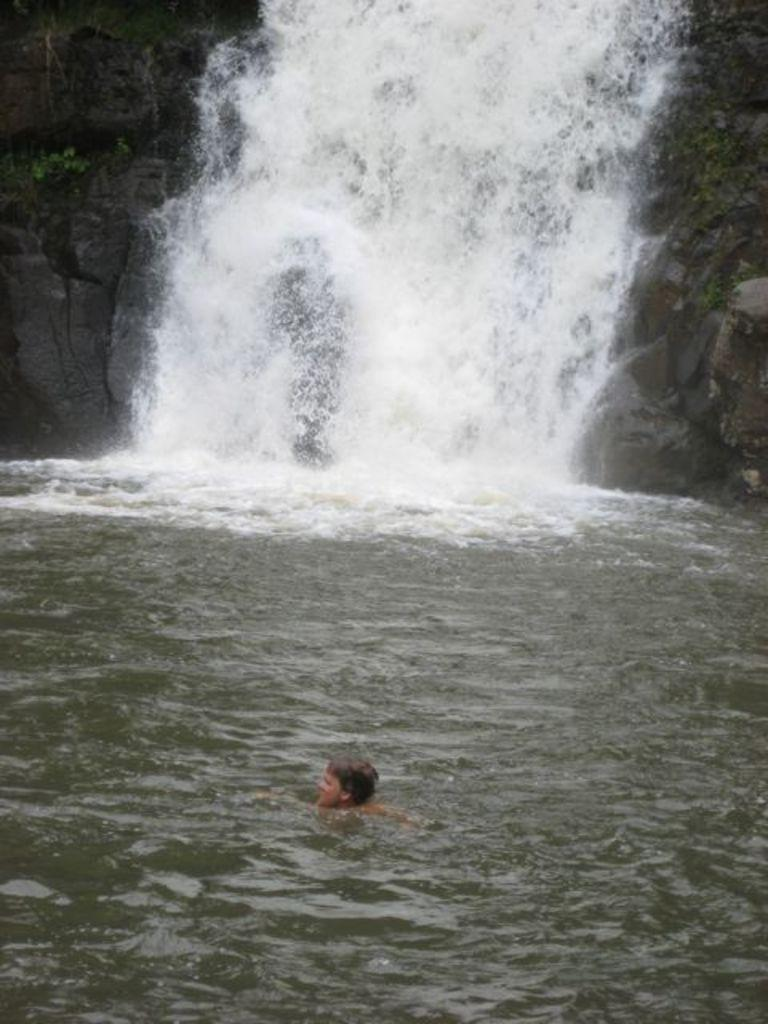What is the man doing in the image? The man is in a water body. What can be observed about the water in the image? There is water flow visible in the image. What type of vegetation is present in the image? There are plants in the image. What other object can be seen in the water body? There is a rock in the image. How does the man express love to the plants in the image? There is no indication of love or affection being expressed in the image; the man is simply in the water body. 